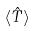<formula> <loc_0><loc_0><loc_500><loc_500>\langle \hat { T } \rangle</formula> 